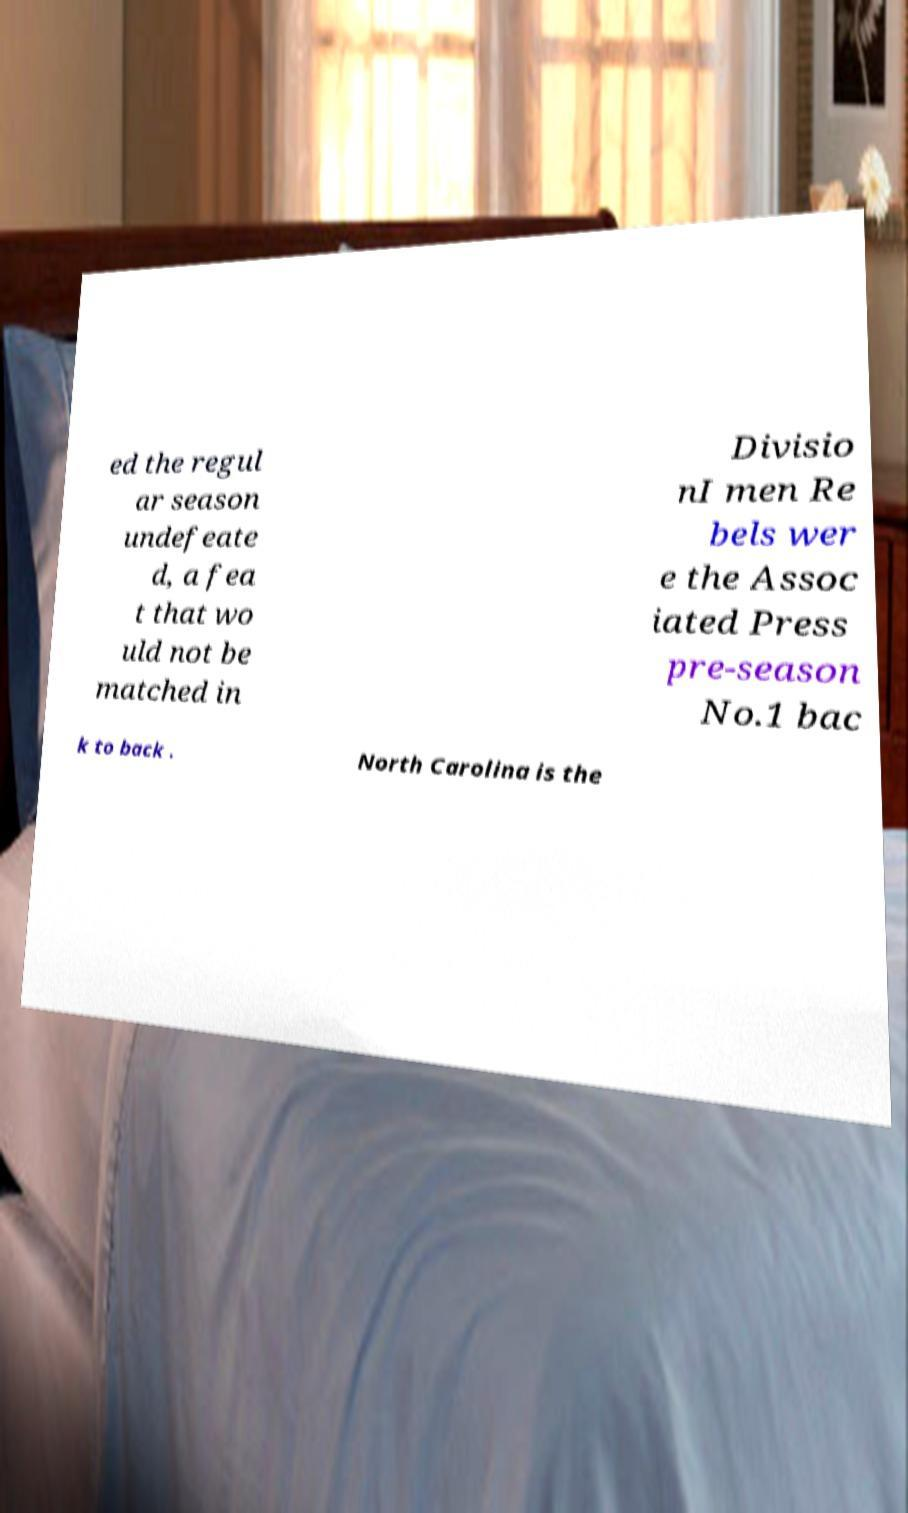Can you read and provide the text displayed in the image?This photo seems to have some interesting text. Can you extract and type it out for me? ed the regul ar season undefeate d, a fea t that wo uld not be matched in Divisio nI men Re bels wer e the Assoc iated Press pre-season No.1 bac k to back . North Carolina is the 